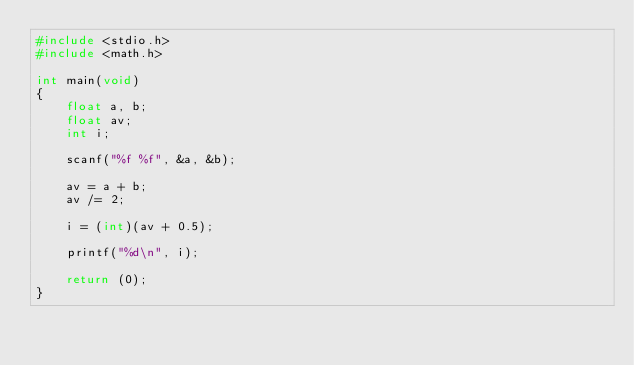Convert code to text. <code><loc_0><loc_0><loc_500><loc_500><_C_>#include <stdio.h>
#include <math.h>

int main(void)
{
	float a, b;
	float av;
	int i;
	
	scanf("%f %f", &a, &b);
	
	av = a + b;
	av /= 2;
	
	i = (int)(av + 0.5);
	
	printf("%d\n", i);
	
	return (0);
}</code> 